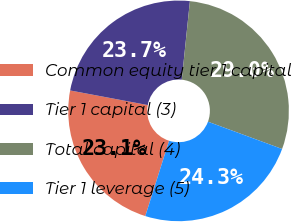Convert chart. <chart><loc_0><loc_0><loc_500><loc_500><pie_chart><fcel>Common equity tier 1 capital<fcel>Tier 1 capital (3)<fcel>Total capital (4)<fcel>Tier 1 leverage (5)<nl><fcel>23.09%<fcel>23.68%<fcel>28.97%<fcel>24.26%<nl></chart> 